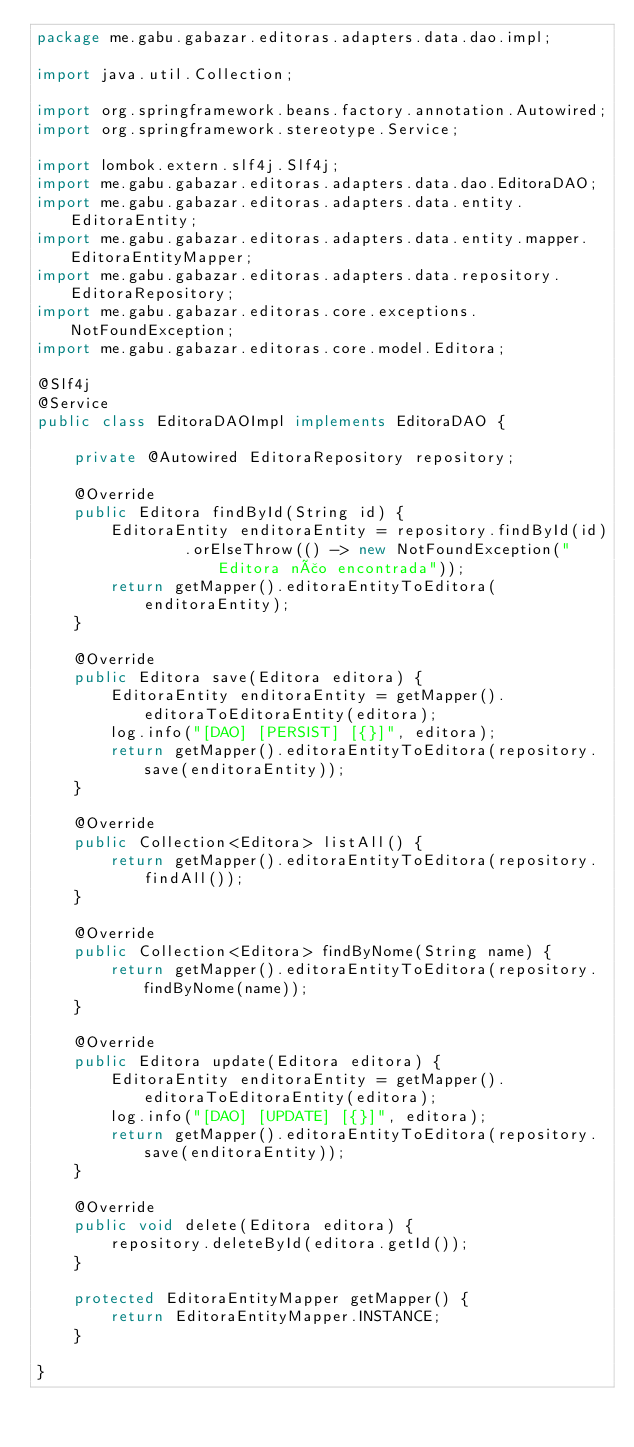<code> <loc_0><loc_0><loc_500><loc_500><_Java_>package me.gabu.gabazar.editoras.adapters.data.dao.impl;

import java.util.Collection;

import org.springframework.beans.factory.annotation.Autowired;
import org.springframework.stereotype.Service;

import lombok.extern.slf4j.Slf4j;
import me.gabu.gabazar.editoras.adapters.data.dao.EditoraDAO;
import me.gabu.gabazar.editoras.adapters.data.entity.EditoraEntity;
import me.gabu.gabazar.editoras.adapters.data.entity.mapper.EditoraEntityMapper;
import me.gabu.gabazar.editoras.adapters.data.repository.EditoraRepository;
import me.gabu.gabazar.editoras.core.exceptions.NotFoundException;
import me.gabu.gabazar.editoras.core.model.Editora;

@Slf4j
@Service
public class EditoraDAOImpl implements EditoraDAO {

    private @Autowired EditoraRepository repository;

    @Override
    public Editora findById(String id) {
        EditoraEntity enditoraEntity = repository.findById(id)
                .orElseThrow(() -> new NotFoundException("Editora não encontrada"));
        return getMapper().editoraEntityToEditora(enditoraEntity);
    }

    @Override
    public Editora save(Editora editora) {
        EditoraEntity enditoraEntity = getMapper().editoraToEditoraEntity(editora);
        log.info("[DAO] [PERSIST] [{}]", editora);
        return getMapper().editoraEntityToEditora(repository.save(enditoraEntity));
    }

    @Override
    public Collection<Editora> listAll() {
        return getMapper().editoraEntityToEditora(repository.findAll());
    }

    @Override
    public Collection<Editora> findByNome(String name) {
        return getMapper().editoraEntityToEditora(repository.findByNome(name));
    }

    @Override
    public Editora update(Editora editora) {
        EditoraEntity enditoraEntity = getMapper().editoraToEditoraEntity(editora);
        log.info("[DAO] [UPDATE] [{}]", editora);
        return getMapper().editoraEntityToEditora(repository.save(enditoraEntity));
    }

    @Override
    public void delete(Editora editora) {
        repository.deleteById(editora.getId());
    }

    protected EditoraEntityMapper getMapper() {
        return EditoraEntityMapper.INSTANCE;
    }

}
</code> 